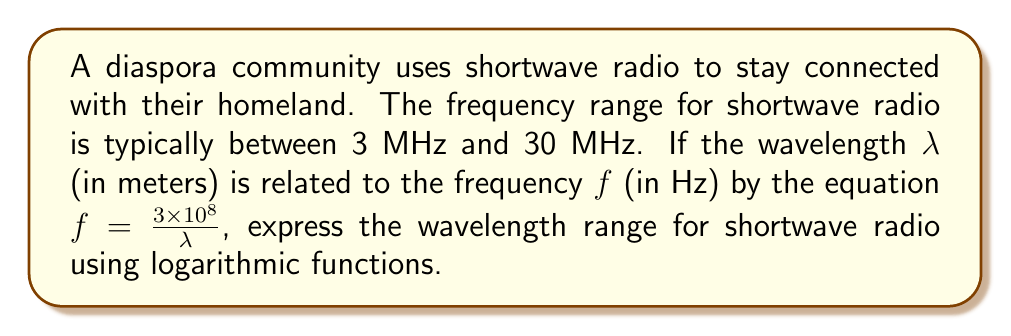What is the answer to this math problem? 1) First, let's convert the frequency range to Hz:
   3 MHz = $3 \times 10^6$ Hz
   30 MHz = $3 \times 10^7$ Hz

2) Now, we can use the given equation to find the wavelength:
   $\lambda = \frac{3 \times 10^8}{f}$

3) For the lower frequency limit:
   $\lambda_{max} = \frac{3 \times 10^8}{3 \times 10^6} = 100$ meters

4) For the upper frequency limit:
   $\lambda_{min} = \frac{3 \times 10^8}{3 \times 10^7} = 10$ meters

5) To express this range using logarithmic functions, we can use the base-10 logarithm:
   $\log_{10}(10) \leq \log_{10}(\lambda) \leq \log_{10}(100)$

6) Simplify:
   $1 \leq \log_{10}(\lambda) \leq 2$

Therefore, the wavelength range for shortwave radio can be expressed as:
$$1 \leq \log_{10}(\lambda) \leq 2$$
where λ is measured in meters.
Answer: $1 \leq \log_{10}(\lambda) \leq 2$, λ in meters 